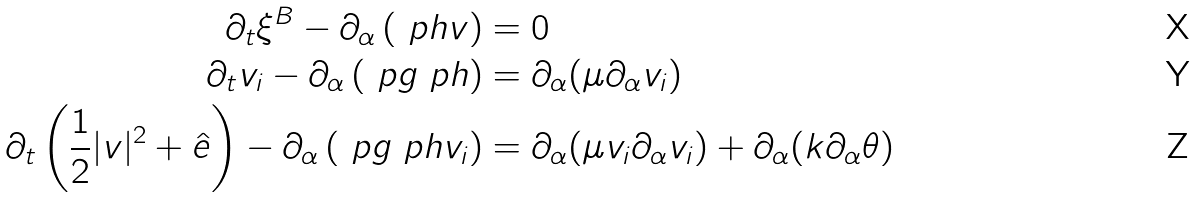Convert formula to latex. <formula><loc_0><loc_0><loc_500><loc_500>\partial _ { t } \xi ^ { B } - \partial _ { \alpha } \left ( \ p h v \right ) & = 0 \\ \partial _ { t } v _ { i } - \partial _ { \alpha } \left ( \ p g \ p h \right ) & = \partial _ { \alpha } ( \mu \partial _ { \alpha } v _ { i } ) \\ \partial _ { t } \left ( \frac { 1 } { 2 } | v | ^ { 2 } + \hat { e } \right ) - \partial _ { \alpha } \left ( \ p g \ p h v _ { i } \right ) & = \partial _ { \alpha } ( \mu v _ { i } \partial _ { \alpha } v _ { i } ) + \partial _ { \alpha } ( k \partial _ { \alpha } \theta )</formula> 